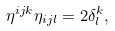Convert formula to latex. <formula><loc_0><loc_0><loc_500><loc_500>\eta ^ { i j k } \eta _ { i j l } = 2 \delta _ { l } ^ { k } ,</formula> 